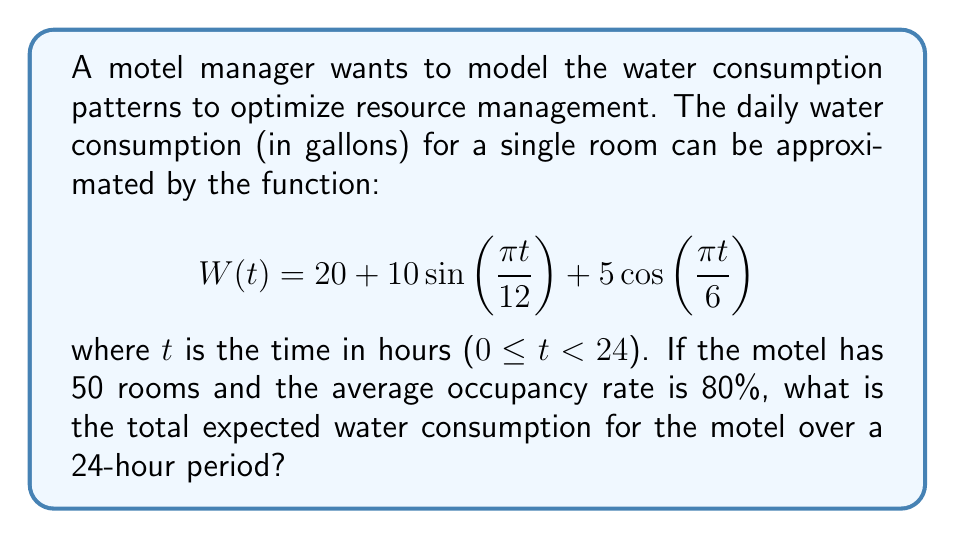Solve this math problem. To solve this problem, we need to follow these steps:

1) First, we need to find the total water consumption for a single room over 24 hours. This can be done by integrating the given function W(t) from 0 to 24:

   $$\int_0^{24} W(t) dt = \int_0^{24} \left(20 + 10\sin\left(\frac{\pi t}{12}\right) + 5\cos\left(\frac{\pi t}{6}\right)\right) dt$$

2) Let's break this integral into three parts:

   Part 1: $$\int_0^{24} 20 dt = 20t \bigg|_0^{24} = 480$$

   Part 2: $$\int_0^{24} 10\sin\left(\frac{\pi t}{12}\right) dt = -\frac{120}{\pi}\cos\left(\frac{\pi t}{12}\right) \bigg|_0^{24} = 0$$

   Part 3: $$\int_0^{24} 5\cos\left(\frac{\pi t}{6}\right) dt = \frac{30}{\pi}\sin\left(\frac{\pi t}{6}\right) \bigg|_0^{24} = 0$$

3) The total for a single room over 24 hours is therefore 480 gallons.

4) The motel has 50 rooms, but the average occupancy rate is 80%. So the number of occupied rooms is:

   $$50 \times 0.80 = 40 \text{ rooms}$$

5) Therefore, the total expected water consumption for the motel over a 24-hour period is:

   $$480 \text{ gallons} \times 40 \text{ rooms} = 19,200 \text{ gallons}$$
Answer: 19,200 gallons 